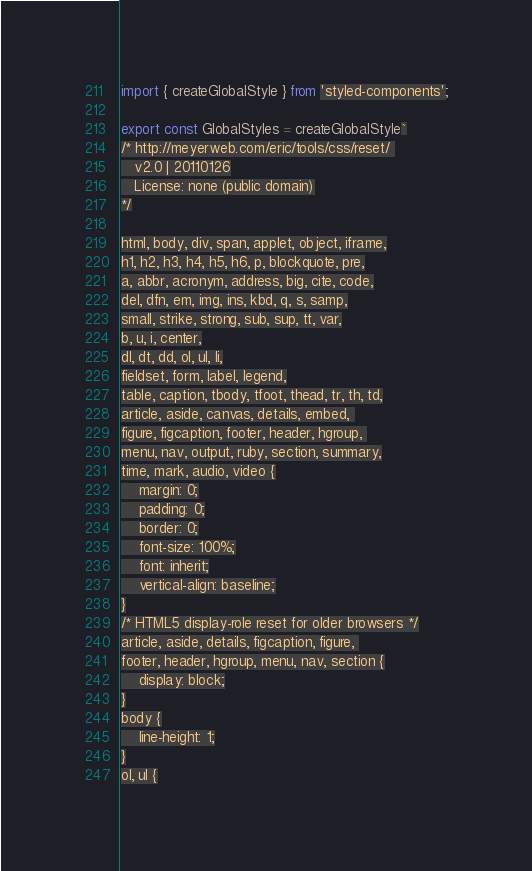<code> <loc_0><loc_0><loc_500><loc_500><_JavaScript_>import { createGlobalStyle } from 'styled-components';

export const GlobalStyles = createGlobalStyle`
/* http://meyerweb.com/eric/tools/css/reset/ 
   v2.0 | 20110126
   License: none (public domain)
*/

html, body, div, span, applet, object, iframe,
h1, h2, h3, h4, h5, h6, p, blockquote, pre,
a, abbr, acronym, address, big, cite, code,
del, dfn, em, img, ins, kbd, q, s, samp,
small, strike, strong, sub, sup, tt, var,
b, u, i, center,
dl, dt, dd, ol, ul, li,
fieldset, form, label, legend,
table, caption, tbody, tfoot, thead, tr, th, td,
article, aside, canvas, details, embed, 
figure, figcaption, footer, header, hgroup, 
menu, nav, output, ruby, section, summary,
time, mark, audio, video {
	margin: 0;
	padding: 0;
	border: 0;
	font-size: 100%;
	font: inherit;
	vertical-align: baseline;
}
/* HTML5 display-role reset for older browsers */
article, aside, details, figcaption, figure, 
footer, header, hgroup, menu, nav, section {
	display: block;
}
body {
	line-height: 1;
}
ol, ul {</code> 